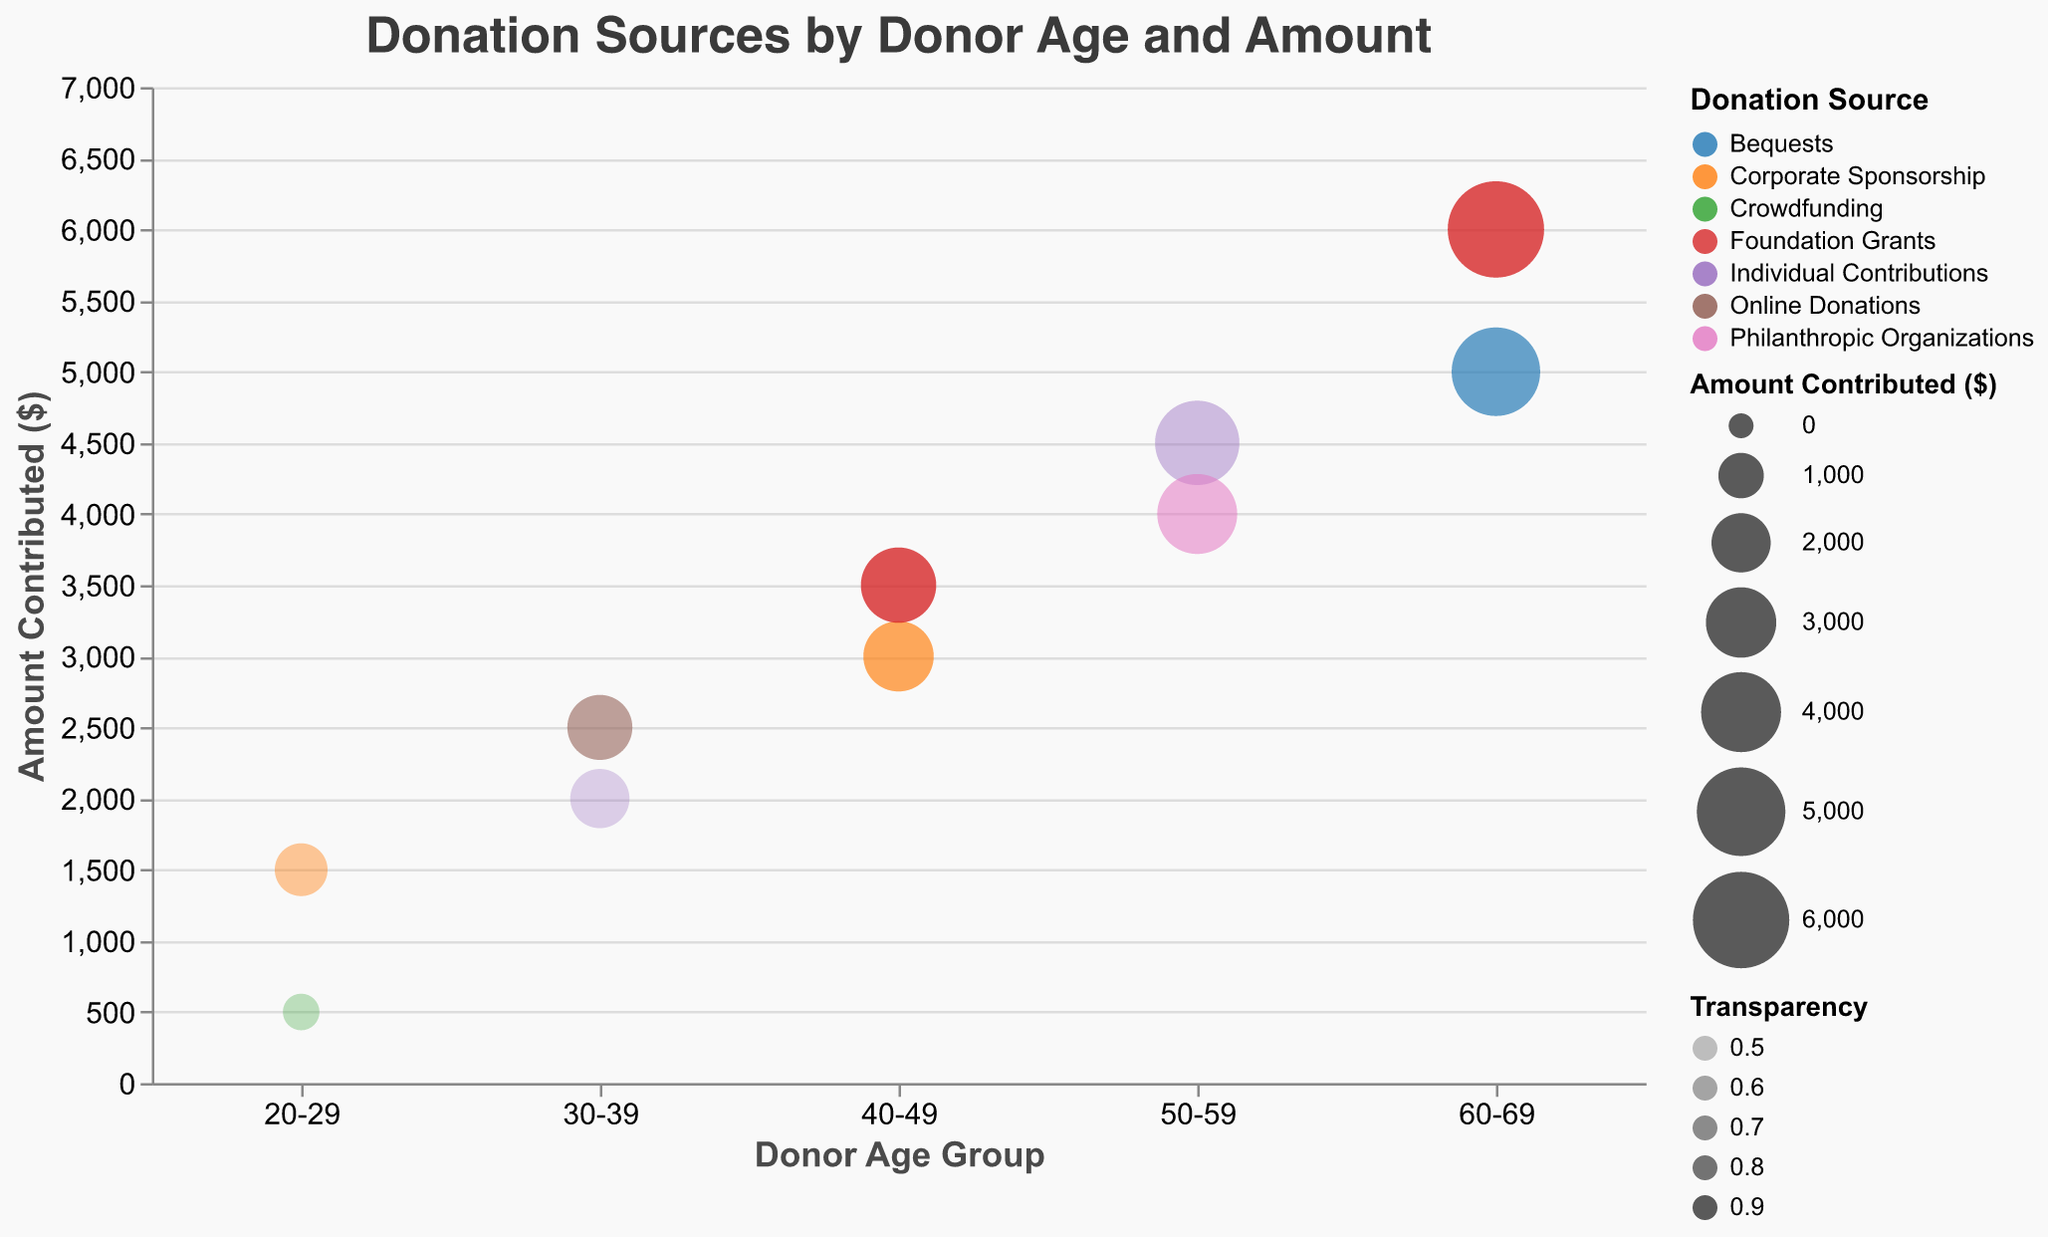What is the title of the figure? The title is displayed at the top of the figure, reading "Donation Sources by Donor Age and Amount."
Answer: "Donation Sources by Donor Age and Amount" What are the two axes labeled as? The x-axis is labeled "Donor Age Group," and the y-axis is labeled "Amount Contributed ($)."
Answer: "Donor Age Group" and "Amount Contributed ($)" Which donation source category has the highest amount contributed? To find the highest amount, look at the bubbles with the greatest y value. The donation source associated with the highest y-value bubble is "Foundation Grants" for the age group 60-69 with $6000 contributed.
Answer: Foundation Grants How many unique age groups are represented in the chart? Examine the x-axis for distinct categories. There are 5 distinct age groups: "20-29," "30-39," "40-49," "50-59," and "60-69."
Answer: 5 Which age group has the greater total contribution amount, 50-59 or 60-69? Sum the contributions for each group: for 50-59: $4500 + $4000 = $8500, and for 60-69: $5000 + $6000 = $11000. Comparing the totals, 60-69 has the greater sum.
Answer: 60-69 Which donation source occurs most frequently among the age groups? Count the occurrences of each donation source across the x-axis categories. "Foundation Grants" appears 2 times in the plot for age groups 40-49 and 60-69. However, other categories also appear 2 times. Detailed examination shows no donation source appears more frequently.
Answer: Foundation Grants (or tied with others) What is the transparency value for the "Corporate Sponsorship" contributions from the 20-29 and 40-49 age groups? Look at the transparency values for the specific bubbles. 20-29 Corporate Sponsorship has a transparency of 0.6, and 40-49 Corporate Sponsorship has a transparency of 0.8.
Answer: 0.6 (20-29), 0.8 (40-49) What is the total amount contributed by the 40-49 age group? Add the contributions for this group: $3000 (Corporate Sponsorship) + $3500 (Foundation Grants) = $6500.
Answer: $6500 Which donation source contributed by the 30-39 age group has a higher transparency level? Compare the transparency values for the two contributions: Online Donations have 0.7, and Individual Contributions have 0.5. The higher value is 0.7 for Online Donations.
Answer: Online Donations Which age group has the smallest bubble size in the chart? Bubble size correlates with amounts contributed, look for the smallest bubble which corresponds to age group 20-29 with $500 from Crowdfunding.
Answer: 20-29 